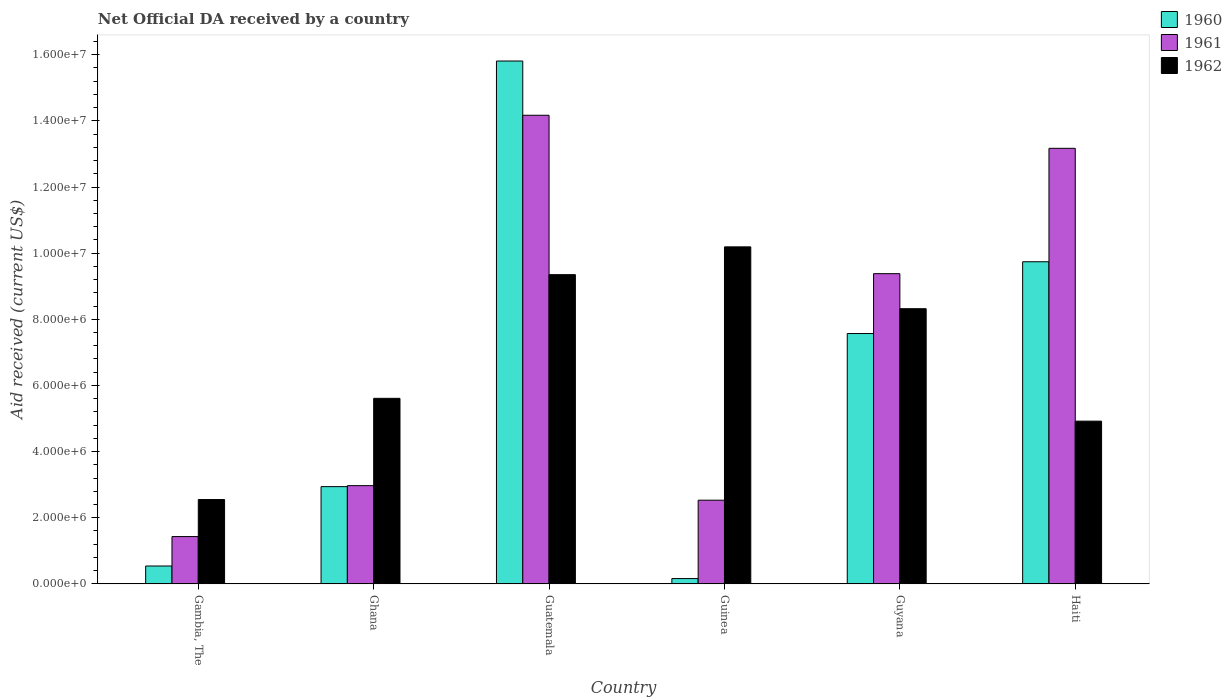Are the number of bars on each tick of the X-axis equal?
Give a very brief answer. Yes. How many bars are there on the 5th tick from the left?
Provide a succinct answer. 3. How many bars are there on the 6th tick from the right?
Your answer should be compact. 3. In how many cases, is the number of bars for a given country not equal to the number of legend labels?
Provide a short and direct response. 0. What is the net official development assistance aid received in 1962 in Haiti?
Your answer should be compact. 4.92e+06. Across all countries, what is the maximum net official development assistance aid received in 1961?
Provide a short and direct response. 1.42e+07. Across all countries, what is the minimum net official development assistance aid received in 1962?
Provide a succinct answer. 2.55e+06. In which country was the net official development assistance aid received in 1962 maximum?
Ensure brevity in your answer.  Guinea. In which country was the net official development assistance aid received in 1960 minimum?
Provide a short and direct response. Guinea. What is the total net official development assistance aid received in 1961 in the graph?
Offer a very short reply. 4.36e+07. What is the difference between the net official development assistance aid received in 1960 in Ghana and that in Guatemala?
Make the answer very short. -1.29e+07. What is the difference between the net official development assistance aid received in 1961 in Guyana and the net official development assistance aid received in 1960 in Guinea?
Offer a terse response. 9.22e+06. What is the average net official development assistance aid received in 1962 per country?
Make the answer very short. 6.82e+06. What is the difference between the net official development assistance aid received of/in 1961 and net official development assistance aid received of/in 1962 in Guatemala?
Make the answer very short. 4.82e+06. What is the ratio of the net official development assistance aid received in 1961 in Ghana to that in Haiti?
Offer a terse response. 0.23. Is the net official development assistance aid received in 1961 in Guatemala less than that in Guinea?
Make the answer very short. No. Is the difference between the net official development assistance aid received in 1961 in Guinea and Guyana greater than the difference between the net official development assistance aid received in 1962 in Guinea and Guyana?
Ensure brevity in your answer.  No. What is the difference between the highest and the lowest net official development assistance aid received in 1960?
Offer a very short reply. 1.56e+07. Is it the case that in every country, the sum of the net official development assistance aid received in 1962 and net official development assistance aid received in 1961 is greater than the net official development assistance aid received in 1960?
Your answer should be compact. Yes. Are all the bars in the graph horizontal?
Offer a very short reply. No. How many countries are there in the graph?
Give a very brief answer. 6. What is the difference between two consecutive major ticks on the Y-axis?
Offer a very short reply. 2.00e+06. Does the graph contain any zero values?
Provide a short and direct response. No. Where does the legend appear in the graph?
Your answer should be very brief. Top right. How are the legend labels stacked?
Provide a succinct answer. Vertical. What is the title of the graph?
Offer a terse response. Net Official DA received by a country. What is the label or title of the Y-axis?
Your response must be concise. Aid received (current US$). What is the Aid received (current US$) of 1960 in Gambia, The?
Make the answer very short. 5.40e+05. What is the Aid received (current US$) in 1961 in Gambia, The?
Provide a succinct answer. 1.43e+06. What is the Aid received (current US$) of 1962 in Gambia, The?
Offer a very short reply. 2.55e+06. What is the Aid received (current US$) of 1960 in Ghana?
Provide a succinct answer. 2.94e+06. What is the Aid received (current US$) of 1961 in Ghana?
Your answer should be very brief. 2.97e+06. What is the Aid received (current US$) of 1962 in Ghana?
Your answer should be very brief. 5.61e+06. What is the Aid received (current US$) of 1960 in Guatemala?
Provide a succinct answer. 1.58e+07. What is the Aid received (current US$) in 1961 in Guatemala?
Your response must be concise. 1.42e+07. What is the Aid received (current US$) in 1962 in Guatemala?
Your answer should be very brief. 9.35e+06. What is the Aid received (current US$) of 1961 in Guinea?
Provide a short and direct response. 2.53e+06. What is the Aid received (current US$) in 1962 in Guinea?
Your answer should be compact. 1.02e+07. What is the Aid received (current US$) in 1960 in Guyana?
Ensure brevity in your answer.  7.57e+06. What is the Aid received (current US$) of 1961 in Guyana?
Provide a succinct answer. 9.38e+06. What is the Aid received (current US$) of 1962 in Guyana?
Provide a short and direct response. 8.32e+06. What is the Aid received (current US$) in 1960 in Haiti?
Your answer should be compact. 9.74e+06. What is the Aid received (current US$) in 1961 in Haiti?
Offer a terse response. 1.32e+07. What is the Aid received (current US$) of 1962 in Haiti?
Make the answer very short. 4.92e+06. Across all countries, what is the maximum Aid received (current US$) of 1960?
Offer a terse response. 1.58e+07. Across all countries, what is the maximum Aid received (current US$) of 1961?
Your answer should be compact. 1.42e+07. Across all countries, what is the maximum Aid received (current US$) of 1962?
Ensure brevity in your answer.  1.02e+07. Across all countries, what is the minimum Aid received (current US$) in 1961?
Keep it short and to the point. 1.43e+06. Across all countries, what is the minimum Aid received (current US$) in 1962?
Offer a terse response. 2.55e+06. What is the total Aid received (current US$) of 1960 in the graph?
Ensure brevity in your answer.  3.68e+07. What is the total Aid received (current US$) in 1961 in the graph?
Provide a short and direct response. 4.36e+07. What is the total Aid received (current US$) in 1962 in the graph?
Your answer should be compact. 4.09e+07. What is the difference between the Aid received (current US$) in 1960 in Gambia, The and that in Ghana?
Give a very brief answer. -2.40e+06. What is the difference between the Aid received (current US$) in 1961 in Gambia, The and that in Ghana?
Your answer should be compact. -1.54e+06. What is the difference between the Aid received (current US$) in 1962 in Gambia, The and that in Ghana?
Make the answer very short. -3.06e+06. What is the difference between the Aid received (current US$) in 1960 in Gambia, The and that in Guatemala?
Make the answer very short. -1.53e+07. What is the difference between the Aid received (current US$) of 1961 in Gambia, The and that in Guatemala?
Provide a succinct answer. -1.27e+07. What is the difference between the Aid received (current US$) in 1962 in Gambia, The and that in Guatemala?
Offer a terse response. -6.80e+06. What is the difference between the Aid received (current US$) of 1961 in Gambia, The and that in Guinea?
Your response must be concise. -1.10e+06. What is the difference between the Aid received (current US$) of 1962 in Gambia, The and that in Guinea?
Provide a short and direct response. -7.64e+06. What is the difference between the Aid received (current US$) in 1960 in Gambia, The and that in Guyana?
Offer a very short reply. -7.03e+06. What is the difference between the Aid received (current US$) in 1961 in Gambia, The and that in Guyana?
Make the answer very short. -7.95e+06. What is the difference between the Aid received (current US$) in 1962 in Gambia, The and that in Guyana?
Give a very brief answer. -5.77e+06. What is the difference between the Aid received (current US$) of 1960 in Gambia, The and that in Haiti?
Keep it short and to the point. -9.20e+06. What is the difference between the Aid received (current US$) in 1961 in Gambia, The and that in Haiti?
Provide a short and direct response. -1.17e+07. What is the difference between the Aid received (current US$) in 1962 in Gambia, The and that in Haiti?
Offer a terse response. -2.37e+06. What is the difference between the Aid received (current US$) of 1960 in Ghana and that in Guatemala?
Keep it short and to the point. -1.29e+07. What is the difference between the Aid received (current US$) in 1961 in Ghana and that in Guatemala?
Keep it short and to the point. -1.12e+07. What is the difference between the Aid received (current US$) in 1962 in Ghana and that in Guatemala?
Give a very brief answer. -3.74e+06. What is the difference between the Aid received (current US$) of 1960 in Ghana and that in Guinea?
Provide a succinct answer. 2.78e+06. What is the difference between the Aid received (current US$) of 1961 in Ghana and that in Guinea?
Provide a succinct answer. 4.40e+05. What is the difference between the Aid received (current US$) of 1962 in Ghana and that in Guinea?
Offer a very short reply. -4.58e+06. What is the difference between the Aid received (current US$) of 1960 in Ghana and that in Guyana?
Your response must be concise. -4.63e+06. What is the difference between the Aid received (current US$) of 1961 in Ghana and that in Guyana?
Offer a terse response. -6.41e+06. What is the difference between the Aid received (current US$) in 1962 in Ghana and that in Guyana?
Keep it short and to the point. -2.71e+06. What is the difference between the Aid received (current US$) in 1960 in Ghana and that in Haiti?
Provide a short and direct response. -6.80e+06. What is the difference between the Aid received (current US$) in 1961 in Ghana and that in Haiti?
Provide a short and direct response. -1.02e+07. What is the difference between the Aid received (current US$) in 1962 in Ghana and that in Haiti?
Your response must be concise. 6.90e+05. What is the difference between the Aid received (current US$) in 1960 in Guatemala and that in Guinea?
Offer a terse response. 1.56e+07. What is the difference between the Aid received (current US$) in 1961 in Guatemala and that in Guinea?
Ensure brevity in your answer.  1.16e+07. What is the difference between the Aid received (current US$) of 1962 in Guatemala and that in Guinea?
Give a very brief answer. -8.40e+05. What is the difference between the Aid received (current US$) in 1960 in Guatemala and that in Guyana?
Keep it short and to the point. 8.24e+06. What is the difference between the Aid received (current US$) of 1961 in Guatemala and that in Guyana?
Make the answer very short. 4.79e+06. What is the difference between the Aid received (current US$) of 1962 in Guatemala and that in Guyana?
Provide a short and direct response. 1.03e+06. What is the difference between the Aid received (current US$) of 1960 in Guatemala and that in Haiti?
Ensure brevity in your answer.  6.07e+06. What is the difference between the Aid received (current US$) of 1962 in Guatemala and that in Haiti?
Offer a very short reply. 4.43e+06. What is the difference between the Aid received (current US$) in 1960 in Guinea and that in Guyana?
Your answer should be compact. -7.41e+06. What is the difference between the Aid received (current US$) of 1961 in Guinea and that in Guyana?
Provide a short and direct response. -6.85e+06. What is the difference between the Aid received (current US$) in 1962 in Guinea and that in Guyana?
Make the answer very short. 1.87e+06. What is the difference between the Aid received (current US$) of 1960 in Guinea and that in Haiti?
Give a very brief answer. -9.58e+06. What is the difference between the Aid received (current US$) of 1961 in Guinea and that in Haiti?
Your answer should be very brief. -1.06e+07. What is the difference between the Aid received (current US$) in 1962 in Guinea and that in Haiti?
Keep it short and to the point. 5.27e+06. What is the difference between the Aid received (current US$) of 1960 in Guyana and that in Haiti?
Make the answer very short. -2.17e+06. What is the difference between the Aid received (current US$) in 1961 in Guyana and that in Haiti?
Your response must be concise. -3.79e+06. What is the difference between the Aid received (current US$) in 1962 in Guyana and that in Haiti?
Provide a short and direct response. 3.40e+06. What is the difference between the Aid received (current US$) of 1960 in Gambia, The and the Aid received (current US$) of 1961 in Ghana?
Your answer should be compact. -2.43e+06. What is the difference between the Aid received (current US$) of 1960 in Gambia, The and the Aid received (current US$) of 1962 in Ghana?
Your response must be concise. -5.07e+06. What is the difference between the Aid received (current US$) of 1961 in Gambia, The and the Aid received (current US$) of 1962 in Ghana?
Offer a terse response. -4.18e+06. What is the difference between the Aid received (current US$) in 1960 in Gambia, The and the Aid received (current US$) in 1961 in Guatemala?
Your answer should be very brief. -1.36e+07. What is the difference between the Aid received (current US$) in 1960 in Gambia, The and the Aid received (current US$) in 1962 in Guatemala?
Keep it short and to the point. -8.81e+06. What is the difference between the Aid received (current US$) of 1961 in Gambia, The and the Aid received (current US$) of 1962 in Guatemala?
Make the answer very short. -7.92e+06. What is the difference between the Aid received (current US$) of 1960 in Gambia, The and the Aid received (current US$) of 1961 in Guinea?
Provide a succinct answer. -1.99e+06. What is the difference between the Aid received (current US$) in 1960 in Gambia, The and the Aid received (current US$) in 1962 in Guinea?
Your answer should be very brief. -9.65e+06. What is the difference between the Aid received (current US$) in 1961 in Gambia, The and the Aid received (current US$) in 1962 in Guinea?
Your answer should be very brief. -8.76e+06. What is the difference between the Aid received (current US$) in 1960 in Gambia, The and the Aid received (current US$) in 1961 in Guyana?
Provide a succinct answer. -8.84e+06. What is the difference between the Aid received (current US$) of 1960 in Gambia, The and the Aid received (current US$) of 1962 in Guyana?
Make the answer very short. -7.78e+06. What is the difference between the Aid received (current US$) of 1961 in Gambia, The and the Aid received (current US$) of 1962 in Guyana?
Your answer should be compact. -6.89e+06. What is the difference between the Aid received (current US$) of 1960 in Gambia, The and the Aid received (current US$) of 1961 in Haiti?
Provide a succinct answer. -1.26e+07. What is the difference between the Aid received (current US$) in 1960 in Gambia, The and the Aid received (current US$) in 1962 in Haiti?
Your answer should be compact. -4.38e+06. What is the difference between the Aid received (current US$) in 1961 in Gambia, The and the Aid received (current US$) in 1962 in Haiti?
Provide a short and direct response. -3.49e+06. What is the difference between the Aid received (current US$) of 1960 in Ghana and the Aid received (current US$) of 1961 in Guatemala?
Your answer should be very brief. -1.12e+07. What is the difference between the Aid received (current US$) in 1960 in Ghana and the Aid received (current US$) in 1962 in Guatemala?
Offer a very short reply. -6.41e+06. What is the difference between the Aid received (current US$) of 1961 in Ghana and the Aid received (current US$) of 1962 in Guatemala?
Provide a short and direct response. -6.38e+06. What is the difference between the Aid received (current US$) in 1960 in Ghana and the Aid received (current US$) in 1961 in Guinea?
Your response must be concise. 4.10e+05. What is the difference between the Aid received (current US$) of 1960 in Ghana and the Aid received (current US$) of 1962 in Guinea?
Give a very brief answer. -7.25e+06. What is the difference between the Aid received (current US$) in 1961 in Ghana and the Aid received (current US$) in 1962 in Guinea?
Your answer should be very brief. -7.22e+06. What is the difference between the Aid received (current US$) in 1960 in Ghana and the Aid received (current US$) in 1961 in Guyana?
Offer a very short reply. -6.44e+06. What is the difference between the Aid received (current US$) of 1960 in Ghana and the Aid received (current US$) of 1962 in Guyana?
Ensure brevity in your answer.  -5.38e+06. What is the difference between the Aid received (current US$) in 1961 in Ghana and the Aid received (current US$) in 1962 in Guyana?
Provide a short and direct response. -5.35e+06. What is the difference between the Aid received (current US$) in 1960 in Ghana and the Aid received (current US$) in 1961 in Haiti?
Keep it short and to the point. -1.02e+07. What is the difference between the Aid received (current US$) in 1960 in Ghana and the Aid received (current US$) in 1962 in Haiti?
Provide a succinct answer. -1.98e+06. What is the difference between the Aid received (current US$) in 1961 in Ghana and the Aid received (current US$) in 1962 in Haiti?
Give a very brief answer. -1.95e+06. What is the difference between the Aid received (current US$) of 1960 in Guatemala and the Aid received (current US$) of 1961 in Guinea?
Provide a succinct answer. 1.33e+07. What is the difference between the Aid received (current US$) in 1960 in Guatemala and the Aid received (current US$) in 1962 in Guinea?
Offer a terse response. 5.62e+06. What is the difference between the Aid received (current US$) of 1961 in Guatemala and the Aid received (current US$) of 1962 in Guinea?
Give a very brief answer. 3.98e+06. What is the difference between the Aid received (current US$) of 1960 in Guatemala and the Aid received (current US$) of 1961 in Guyana?
Provide a short and direct response. 6.43e+06. What is the difference between the Aid received (current US$) in 1960 in Guatemala and the Aid received (current US$) in 1962 in Guyana?
Your response must be concise. 7.49e+06. What is the difference between the Aid received (current US$) of 1961 in Guatemala and the Aid received (current US$) of 1962 in Guyana?
Offer a very short reply. 5.85e+06. What is the difference between the Aid received (current US$) of 1960 in Guatemala and the Aid received (current US$) of 1961 in Haiti?
Offer a terse response. 2.64e+06. What is the difference between the Aid received (current US$) in 1960 in Guatemala and the Aid received (current US$) in 1962 in Haiti?
Offer a terse response. 1.09e+07. What is the difference between the Aid received (current US$) of 1961 in Guatemala and the Aid received (current US$) of 1962 in Haiti?
Your answer should be compact. 9.25e+06. What is the difference between the Aid received (current US$) of 1960 in Guinea and the Aid received (current US$) of 1961 in Guyana?
Offer a very short reply. -9.22e+06. What is the difference between the Aid received (current US$) of 1960 in Guinea and the Aid received (current US$) of 1962 in Guyana?
Provide a succinct answer. -8.16e+06. What is the difference between the Aid received (current US$) in 1961 in Guinea and the Aid received (current US$) in 1962 in Guyana?
Provide a short and direct response. -5.79e+06. What is the difference between the Aid received (current US$) in 1960 in Guinea and the Aid received (current US$) in 1961 in Haiti?
Provide a succinct answer. -1.30e+07. What is the difference between the Aid received (current US$) of 1960 in Guinea and the Aid received (current US$) of 1962 in Haiti?
Offer a terse response. -4.76e+06. What is the difference between the Aid received (current US$) of 1961 in Guinea and the Aid received (current US$) of 1962 in Haiti?
Offer a very short reply. -2.39e+06. What is the difference between the Aid received (current US$) in 1960 in Guyana and the Aid received (current US$) in 1961 in Haiti?
Offer a very short reply. -5.60e+06. What is the difference between the Aid received (current US$) in 1960 in Guyana and the Aid received (current US$) in 1962 in Haiti?
Ensure brevity in your answer.  2.65e+06. What is the difference between the Aid received (current US$) of 1961 in Guyana and the Aid received (current US$) of 1962 in Haiti?
Your answer should be very brief. 4.46e+06. What is the average Aid received (current US$) of 1960 per country?
Provide a short and direct response. 6.13e+06. What is the average Aid received (current US$) in 1961 per country?
Your answer should be very brief. 7.28e+06. What is the average Aid received (current US$) in 1962 per country?
Offer a terse response. 6.82e+06. What is the difference between the Aid received (current US$) in 1960 and Aid received (current US$) in 1961 in Gambia, The?
Ensure brevity in your answer.  -8.90e+05. What is the difference between the Aid received (current US$) in 1960 and Aid received (current US$) in 1962 in Gambia, The?
Offer a terse response. -2.01e+06. What is the difference between the Aid received (current US$) of 1961 and Aid received (current US$) of 1962 in Gambia, The?
Ensure brevity in your answer.  -1.12e+06. What is the difference between the Aid received (current US$) of 1960 and Aid received (current US$) of 1961 in Ghana?
Offer a terse response. -3.00e+04. What is the difference between the Aid received (current US$) of 1960 and Aid received (current US$) of 1962 in Ghana?
Your answer should be very brief. -2.67e+06. What is the difference between the Aid received (current US$) of 1961 and Aid received (current US$) of 1962 in Ghana?
Provide a short and direct response. -2.64e+06. What is the difference between the Aid received (current US$) of 1960 and Aid received (current US$) of 1961 in Guatemala?
Provide a short and direct response. 1.64e+06. What is the difference between the Aid received (current US$) of 1960 and Aid received (current US$) of 1962 in Guatemala?
Make the answer very short. 6.46e+06. What is the difference between the Aid received (current US$) of 1961 and Aid received (current US$) of 1962 in Guatemala?
Offer a terse response. 4.82e+06. What is the difference between the Aid received (current US$) in 1960 and Aid received (current US$) in 1961 in Guinea?
Offer a very short reply. -2.37e+06. What is the difference between the Aid received (current US$) of 1960 and Aid received (current US$) of 1962 in Guinea?
Give a very brief answer. -1.00e+07. What is the difference between the Aid received (current US$) of 1961 and Aid received (current US$) of 1962 in Guinea?
Provide a short and direct response. -7.66e+06. What is the difference between the Aid received (current US$) in 1960 and Aid received (current US$) in 1961 in Guyana?
Offer a very short reply. -1.81e+06. What is the difference between the Aid received (current US$) of 1960 and Aid received (current US$) of 1962 in Guyana?
Make the answer very short. -7.50e+05. What is the difference between the Aid received (current US$) in 1961 and Aid received (current US$) in 1962 in Guyana?
Offer a very short reply. 1.06e+06. What is the difference between the Aid received (current US$) in 1960 and Aid received (current US$) in 1961 in Haiti?
Provide a succinct answer. -3.43e+06. What is the difference between the Aid received (current US$) in 1960 and Aid received (current US$) in 1962 in Haiti?
Your answer should be very brief. 4.82e+06. What is the difference between the Aid received (current US$) in 1961 and Aid received (current US$) in 1962 in Haiti?
Your response must be concise. 8.25e+06. What is the ratio of the Aid received (current US$) in 1960 in Gambia, The to that in Ghana?
Your answer should be compact. 0.18. What is the ratio of the Aid received (current US$) of 1961 in Gambia, The to that in Ghana?
Give a very brief answer. 0.48. What is the ratio of the Aid received (current US$) of 1962 in Gambia, The to that in Ghana?
Provide a succinct answer. 0.45. What is the ratio of the Aid received (current US$) in 1960 in Gambia, The to that in Guatemala?
Offer a very short reply. 0.03. What is the ratio of the Aid received (current US$) in 1961 in Gambia, The to that in Guatemala?
Give a very brief answer. 0.1. What is the ratio of the Aid received (current US$) in 1962 in Gambia, The to that in Guatemala?
Your answer should be very brief. 0.27. What is the ratio of the Aid received (current US$) in 1960 in Gambia, The to that in Guinea?
Give a very brief answer. 3.38. What is the ratio of the Aid received (current US$) in 1961 in Gambia, The to that in Guinea?
Make the answer very short. 0.57. What is the ratio of the Aid received (current US$) in 1962 in Gambia, The to that in Guinea?
Provide a succinct answer. 0.25. What is the ratio of the Aid received (current US$) of 1960 in Gambia, The to that in Guyana?
Offer a very short reply. 0.07. What is the ratio of the Aid received (current US$) of 1961 in Gambia, The to that in Guyana?
Provide a succinct answer. 0.15. What is the ratio of the Aid received (current US$) in 1962 in Gambia, The to that in Guyana?
Offer a very short reply. 0.31. What is the ratio of the Aid received (current US$) in 1960 in Gambia, The to that in Haiti?
Offer a very short reply. 0.06. What is the ratio of the Aid received (current US$) of 1961 in Gambia, The to that in Haiti?
Keep it short and to the point. 0.11. What is the ratio of the Aid received (current US$) in 1962 in Gambia, The to that in Haiti?
Your response must be concise. 0.52. What is the ratio of the Aid received (current US$) of 1960 in Ghana to that in Guatemala?
Give a very brief answer. 0.19. What is the ratio of the Aid received (current US$) in 1961 in Ghana to that in Guatemala?
Offer a terse response. 0.21. What is the ratio of the Aid received (current US$) in 1960 in Ghana to that in Guinea?
Ensure brevity in your answer.  18.38. What is the ratio of the Aid received (current US$) in 1961 in Ghana to that in Guinea?
Provide a succinct answer. 1.17. What is the ratio of the Aid received (current US$) of 1962 in Ghana to that in Guinea?
Offer a very short reply. 0.55. What is the ratio of the Aid received (current US$) of 1960 in Ghana to that in Guyana?
Your response must be concise. 0.39. What is the ratio of the Aid received (current US$) in 1961 in Ghana to that in Guyana?
Your answer should be compact. 0.32. What is the ratio of the Aid received (current US$) in 1962 in Ghana to that in Guyana?
Ensure brevity in your answer.  0.67. What is the ratio of the Aid received (current US$) in 1960 in Ghana to that in Haiti?
Provide a short and direct response. 0.3. What is the ratio of the Aid received (current US$) in 1961 in Ghana to that in Haiti?
Offer a very short reply. 0.23. What is the ratio of the Aid received (current US$) in 1962 in Ghana to that in Haiti?
Your answer should be compact. 1.14. What is the ratio of the Aid received (current US$) in 1960 in Guatemala to that in Guinea?
Offer a terse response. 98.81. What is the ratio of the Aid received (current US$) in 1961 in Guatemala to that in Guinea?
Your response must be concise. 5.6. What is the ratio of the Aid received (current US$) in 1962 in Guatemala to that in Guinea?
Your response must be concise. 0.92. What is the ratio of the Aid received (current US$) in 1960 in Guatemala to that in Guyana?
Provide a succinct answer. 2.09. What is the ratio of the Aid received (current US$) in 1961 in Guatemala to that in Guyana?
Ensure brevity in your answer.  1.51. What is the ratio of the Aid received (current US$) of 1962 in Guatemala to that in Guyana?
Your answer should be compact. 1.12. What is the ratio of the Aid received (current US$) in 1960 in Guatemala to that in Haiti?
Your answer should be compact. 1.62. What is the ratio of the Aid received (current US$) of 1961 in Guatemala to that in Haiti?
Your answer should be compact. 1.08. What is the ratio of the Aid received (current US$) in 1962 in Guatemala to that in Haiti?
Provide a short and direct response. 1.9. What is the ratio of the Aid received (current US$) in 1960 in Guinea to that in Guyana?
Your answer should be very brief. 0.02. What is the ratio of the Aid received (current US$) in 1961 in Guinea to that in Guyana?
Ensure brevity in your answer.  0.27. What is the ratio of the Aid received (current US$) of 1962 in Guinea to that in Guyana?
Provide a succinct answer. 1.22. What is the ratio of the Aid received (current US$) of 1960 in Guinea to that in Haiti?
Offer a terse response. 0.02. What is the ratio of the Aid received (current US$) in 1961 in Guinea to that in Haiti?
Your answer should be compact. 0.19. What is the ratio of the Aid received (current US$) in 1962 in Guinea to that in Haiti?
Provide a short and direct response. 2.07. What is the ratio of the Aid received (current US$) of 1960 in Guyana to that in Haiti?
Your answer should be very brief. 0.78. What is the ratio of the Aid received (current US$) of 1961 in Guyana to that in Haiti?
Ensure brevity in your answer.  0.71. What is the ratio of the Aid received (current US$) of 1962 in Guyana to that in Haiti?
Provide a succinct answer. 1.69. What is the difference between the highest and the second highest Aid received (current US$) in 1960?
Make the answer very short. 6.07e+06. What is the difference between the highest and the second highest Aid received (current US$) of 1961?
Your answer should be compact. 1.00e+06. What is the difference between the highest and the second highest Aid received (current US$) of 1962?
Your answer should be compact. 8.40e+05. What is the difference between the highest and the lowest Aid received (current US$) of 1960?
Keep it short and to the point. 1.56e+07. What is the difference between the highest and the lowest Aid received (current US$) in 1961?
Offer a terse response. 1.27e+07. What is the difference between the highest and the lowest Aid received (current US$) in 1962?
Give a very brief answer. 7.64e+06. 